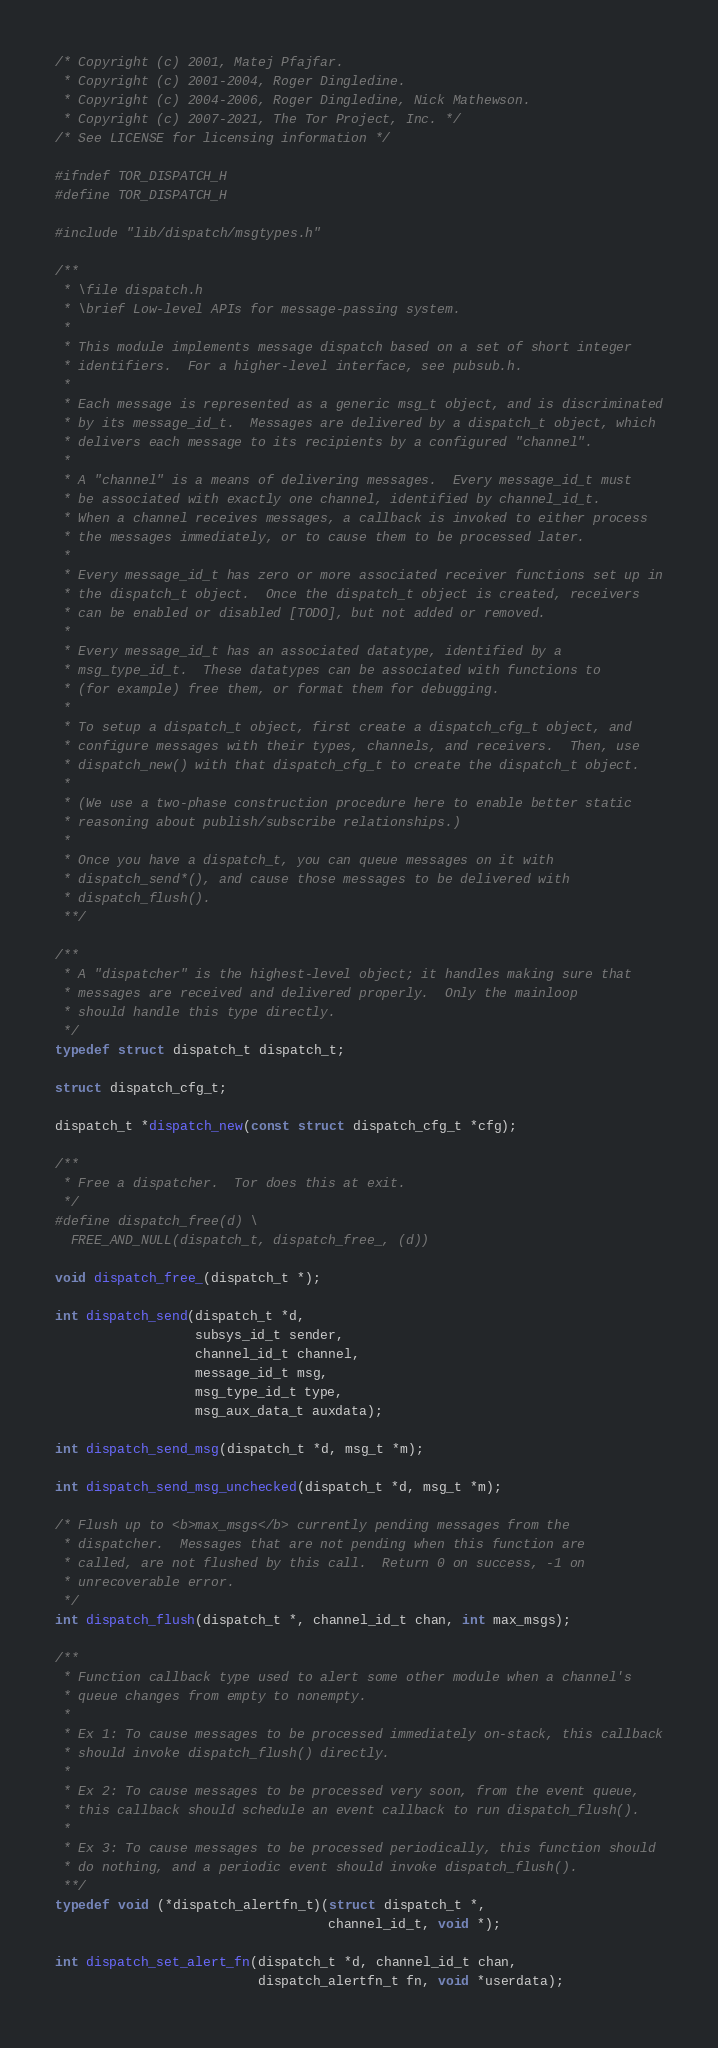<code> <loc_0><loc_0><loc_500><loc_500><_C_>/* Copyright (c) 2001, Matej Pfajfar.
 * Copyright (c) 2001-2004, Roger Dingledine.
 * Copyright (c) 2004-2006, Roger Dingledine, Nick Mathewson.
 * Copyright (c) 2007-2021, The Tor Project, Inc. */
/* See LICENSE for licensing information */

#ifndef TOR_DISPATCH_H
#define TOR_DISPATCH_H

#include "lib/dispatch/msgtypes.h"

/**
 * \file dispatch.h
 * \brief Low-level APIs for message-passing system.
 *
 * This module implements message dispatch based on a set of short integer
 * identifiers.  For a higher-level interface, see pubsub.h.
 *
 * Each message is represented as a generic msg_t object, and is discriminated
 * by its message_id_t.  Messages are delivered by a dispatch_t object, which
 * delivers each message to its recipients by a configured "channel".
 *
 * A "channel" is a means of delivering messages.  Every message_id_t must
 * be associated with exactly one channel, identified by channel_id_t.
 * When a channel receives messages, a callback is invoked to either process
 * the messages immediately, or to cause them to be processed later.
 *
 * Every message_id_t has zero or more associated receiver functions set up in
 * the dispatch_t object.  Once the dispatch_t object is created, receivers
 * can be enabled or disabled [TODO], but not added or removed.
 *
 * Every message_id_t has an associated datatype, identified by a
 * msg_type_id_t.  These datatypes can be associated with functions to
 * (for example) free them, or format them for debugging.
 *
 * To setup a dispatch_t object, first create a dispatch_cfg_t object, and
 * configure messages with their types, channels, and receivers.  Then, use
 * dispatch_new() with that dispatch_cfg_t to create the dispatch_t object.
 *
 * (We use a two-phase construction procedure here to enable better static
 * reasoning about publish/subscribe relationships.)
 *
 * Once you have a dispatch_t, you can queue messages on it with
 * dispatch_send*(), and cause those messages to be delivered with
 * dispatch_flush().
 **/

/**
 * A "dispatcher" is the highest-level object; it handles making sure that
 * messages are received and delivered properly.  Only the mainloop
 * should handle this type directly.
 */
typedef struct dispatch_t dispatch_t;

struct dispatch_cfg_t;

dispatch_t *dispatch_new(const struct dispatch_cfg_t *cfg);

/**
 * Free a dispatcher.  Tor does this at exit.
 */
#define dispatch_free(d) \
  FREE_AND_NULL(dispatch_t, dispatch_free_, (d))

void dispatch_free_(dispatch_t *);

int dispatch_send(dispatch_t *d,
                  subsys_id_t sender,
                  channel_id_t channel,
                  message_id_t msg,
                  msg_type_id_t type,
                  msg_aux_data_t auxdata);

int dispatch_send_msg(dispatch_t *d, msg_t *m);

int dispatch_send_msg_unchecked(dispatch_t *d, msg_t *m);

/* Flush up to <b>max_msgs</b> currently pending messages from the
 * dispatcher.  Messages that are not pending when this function are
 * called, are not flushed by this call.  Return 0 on success, -1 on
 * unrecoverable error.
 */
int dispatch_flush(dispatch_t *, channel_id_t chan, int max_msgs);

/**
 * Function callback type used to alert some other module when a channel's
 * queue changes from empty to nonempty.
 *
 * Ex 1: To cause messages to be processed immediately on-stack, this callback
 * should invoke dispatch_flush() directly.
 *
 * Ex 2: To cause messages to be processed very soon, from the event queue,
 * this callback should schedule an event callback to run dispatch_flush().
 *
 * Ex 3: To cause messages to be processed periodically, this function should
 * do nothing, and a periodic event should invoke dispatch_flush().
 **/
typedef void (*dispatch_alertfn_t)(struct dispatch_t *,
                                   channel_id_t, void *);

int dispatch_set_alert_fn(dispatch_t *d, channel_id_t chan,
                          dispatch_alertfn_t fn, void *userdata);
</code> 